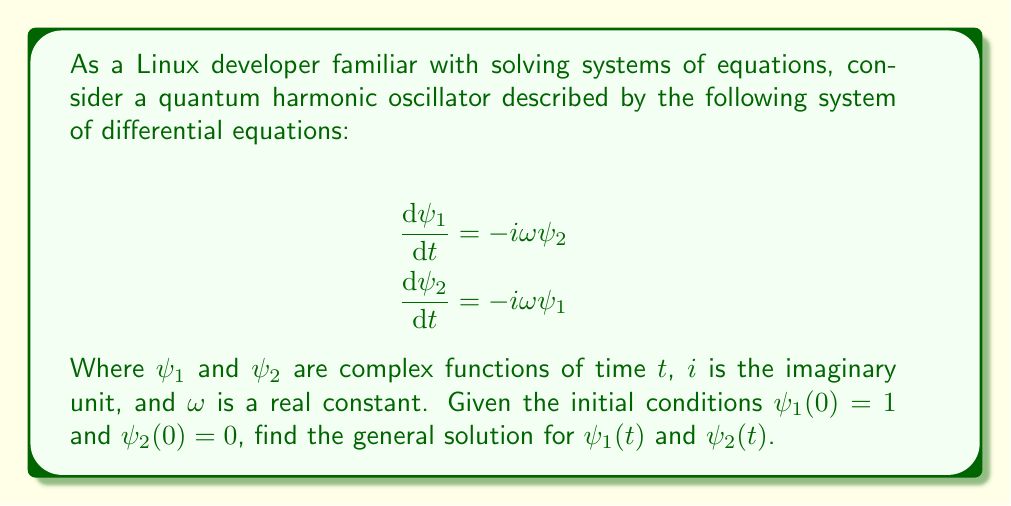Teach me how to tackle this problem. Let's approach this problem step-by-step, similar to how we might approach debugging a complex Linux system:

1) First, we need to recognize that this is a coupled system of first-order differential equations. We can solve this by decoupling the equations.

2) To decouple, we can differentiate one equation and substitute the other:

   $$\frac{d^2\psi_1}{dt^2} = -i\omega\frac{d\psi_2}{dt} = -i\omega(-i\omega\psi_1) = -\omega^2\psi_1$$

3) This is a second-order differential equation for $\psi_1$. The general solution for this equation is:

   $$\psi_1(t) = A e^{i\omega t} + B e^{-i\omega t}$$

   where $A$ and $B$ are complex constants.

4) We can find $\psi_2(t)$ by using the first equation of the original system:

   $$\psi_2(t) = \frac{i}{\omega}\frac{d\psi_1}{dt} = -A e^{i\omega t} + B e^{-i\omega t}$$

5) Now we use the initial conditions to determine $A$ and $B$:

   For $t=0$: $\psi_1(0) = A + B = 1$
              $\psi_2(0) = -A + B = 0$

6) Solving this system of equations:

   $A = \frac{1}{2}$ and $B = \frac{1}{2}$

7) Therefore, the final solutions are:

   $$\psi_1(t) = \frac{1}{2}(e^{i\omega t} + e^{-i\omega t}) = \cos(\omega t)$$
   $$\psi_2(t) = \frac{1}{2}(-e^{i\omega t} + e^{-i\omega t}) = -i\sin(\omega t)$$

This solution method is analogous to breaking down a complex coding problem into smaller, manageable parts, solving each part, and then combining the results.
Answer: $\psi_1(t) = \cos(\omega t)$, $\psi_2(t) = -i\sin(\omega t)$ 